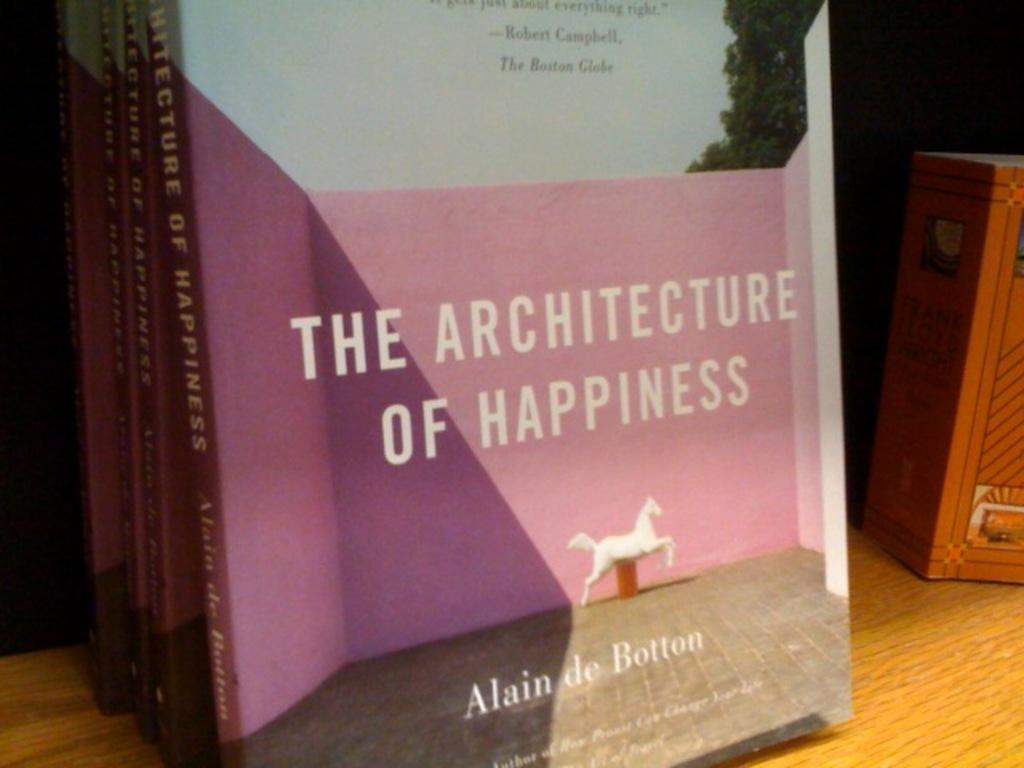<image>
Share a concise interpretation of the image provided. A book cover has the title The Architecture Of Happiness on the front. 